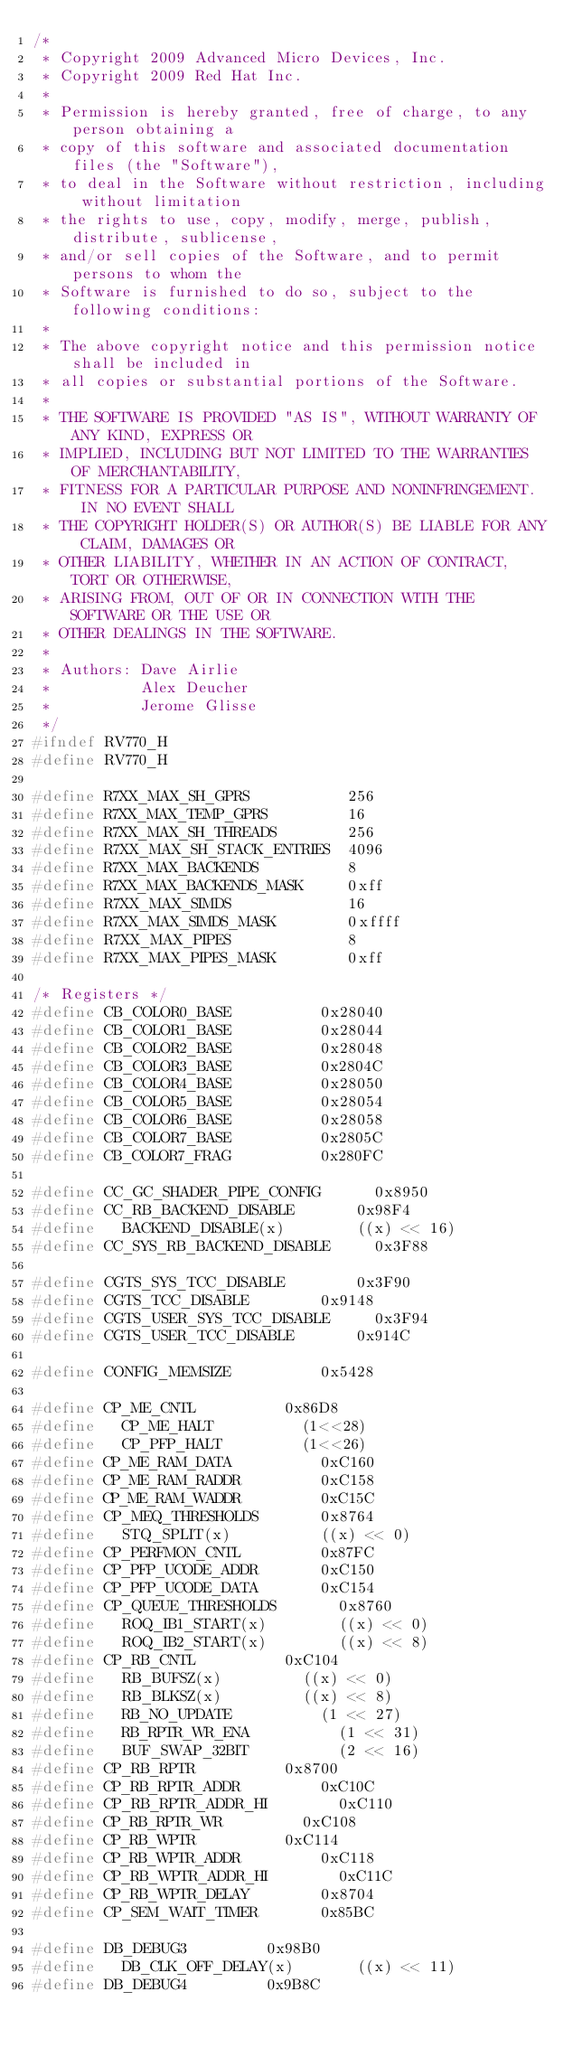Convert code to text. <code><loc_0><loc_0><loc_500><loc_500><_C_>/*
 * Copyright 2009 Advanced Micro Devices, Inc.
 * Copyright 2009 Red Hat Inc.
 *
 * Permission is hereby granted, free of charge, to any person obtaining a
 * copy of this software and associated documentation files (the "Software"),
 * to deal in the Software without restriction, including without limitation
 * the rights to use, copy, modify, merge, publish, distribute, sublicense,
 * and/or sell copies of the Software, and to permit persons to whom the
 * Software is furnished to do so, subject to the following conditions:
 *
 * The above copyright notice and this permission notice shall be included in
 * all copies or substantial portions of the Software.
 *
 * THE SOFTWARE IS PROVIDED "AS IS", WITHOUT WARRANTY OF ANY KIND, EXPRESS OR
 * IMPLIED, INCLUDING BUT NOT LIMITED TO THE WARRANTIES OF MERCHANTABILITY,
 * FITNESS FOR A PARTICULAR PURPOSE AND NONINFRINGEMENT.  IN NO EVENT SHALL
 * THE COPYRIGHT HOLDER(S) OR AUTHOR(S) BE LIABLE FOR ANY CLAIM, DAMAGES OR
 * OTHER LIABILITY, WHETHER IN AN ACTION OF CONTRACT, TORT OR OTHERWISE,
 * ARISING FROM, OUT OF OR IN CONNECTION WITH THE SOFTWARE OR THE USE OR
 * OTHER DEALINGS IN THE SOFTWARE.
 *
 * Authors: Dave Airlie
 *          Alex Deucher
 *          Jerome Glisse
 */
#ifndef RV770_H
#define RV770_H

#define R7XX_MAX_SH_GPRS           256
#define R7XX_MAX_TEMP_GPRS         16
#define R7XX_MAX_SH_THREADS        256
#define R7XX_MAX_SH_STACK_ENTRIES  4096
#define R7XX_MAX_BACKENDS          8
#define R7XX_MAX_BACKENDS_MASK     0xff
#define R7XX_MAX_SIMDS             16
#define R7XX_MAX_SIMDS_MASK        0xffff
#define R7XX_MAX_PIPES             8
#define R7XX_MAX_PIPES_MASK        0xff

/* Registers */
#define	CB_COLOR0_BASE					0x28040
#define	CB_COLOR1_BASE					0x28044
#define	CB_COLOR2_BASE					0x28048
#define	CB_COLOR3_BASE					0x2804C
#define	CB_COLOR4_BASE					0x28050
#define	CB_COLOR5_BASE					0x28054
#define	CB_COLOR6_BASE					0x28058
#define	CB_COLOR7_BASE					0x2805C
#define	CB_COLOR7_FRAG					0x280FC

#define	CC_GC_SHADER_PIPE_CONFIG			0x8950
#define	CC_RB_BACKEND_DISABLE				0x98F4
#define		BACKEND_DISABLE(x)				((x) << 16)
#define	CC_SYS_RB_BACKEND_DISABLE			0x3F88

#define	CGTS_SYS_TCC_DISABLE				0x3F90
#define	CGTS_TCC_DISABLE				0x9148
#define	CGTS_USER_SYS_TCC_DISABLE			0x3F94
#define	CGTS_USER_TCC_DISABLE				0x914C

#define	CONFIG_MEMSIZE					0x5428

#define	CP_ME_CNTL					0x86D8
#define		CP_ME_HALT					(1<<28)
#define		CP_PFP_HALT					(1<<26)
#define	CP_ME_RAM_DATA					0xC160
#define	CP_ME_RAM_RADDR					0xC158
#define	CP_ME_RAM_WADDR					0xC15C
#define CP_MEQ_THRESHOLDS				0x8764
#define		STQ_SPLIT(x)					((x) << 0)
#define	CP_PERFMON_CNTL					0x87FC
#define	CP_PFP_UCODE_ADDR				0xC150
#define	CP_PFP_UCODE_DATA				0xC154
#define	CP_QUEUE_THRESHOLDS				0x8760
#define		ROQ_IB1_START(x)				((x) << 0)
#define		ROQ_IB2_START(x)				((x) << 8)
#define	CP_RB_CNTL					0xC104
#define		RB_BUFSZ(x)					((x) << 0)
#define		RB_BLKSZ(x)					((x) << 8)
#define		RB_NO_UPDATE					(1 << 27)
#define		RB_RPTR_WR_ENA					(1 << 31)
#define		BUF_SWAP_32BIT					(2 << 16)
#define	CP_RB_RPTR					0x8700
#define	CP_RB_RPTR_ADDR					0xC10C
#define	CP_RB_RPTR_ADDR_HI				0xC110
#define	CP_RB_RPTR_WR					0xC108
#define	CP_RB_WPTR					0xC114
#define	CP_RB_WPTR_ADDR					0xC118
#define	CP_RB_WPTR_ADDR_HI				0xC11C
#define	CP_RB_WPTR_DELAY				0x8704
#define	CP_SEM_WAIT_TIMER				0x85BC

#define	DB_DEBUG3					0x98B0
#define		DB_CLK_OFF_DELAY(x)				((x) << 11)
#define DB_DEBUG4					0x9B8C</code> 